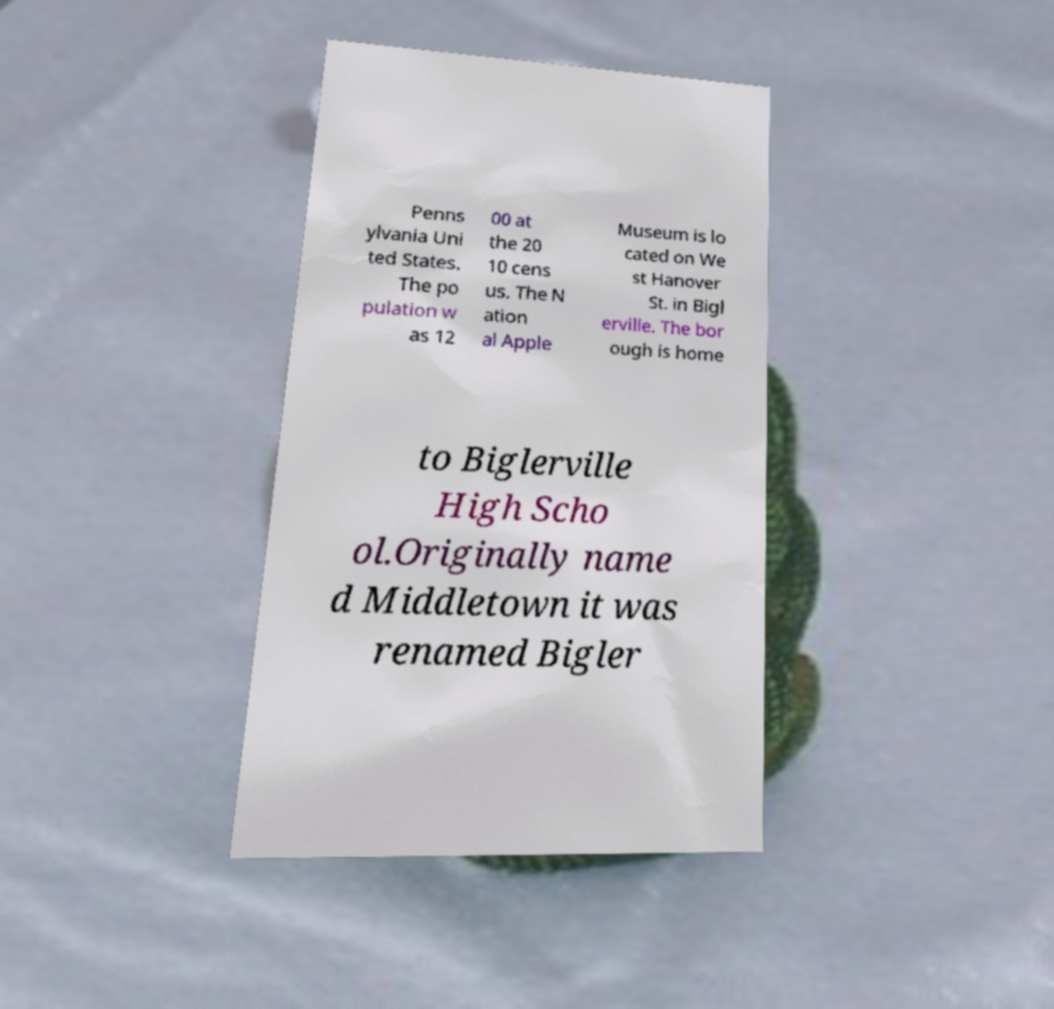I need the written content from this picture converted into text. Can you do that? Penns ylvania Uni ted States. The po pulation w as 12 00 at the 20 10 cens us. The N ation al Apple Museum is lo cated on We st Hanover St. in Bigl erville. The bor ough is home to Biglerville High Scho ol.Originally name d Middletown it was renamed Bigler 